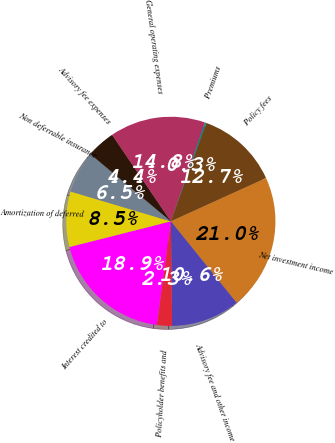<chart> <loc_0><loc_0><loc_500><loc_500><pie_chart><fcel>Premiums<fcel>Policy fees<fcel>Net investment income<fcel>Advisory fee and other income<fcel>Policyholder benefits and<fcel>Interest credited to<fcel>Amortization of deferred<fcel>Non deferrable insurance<fcel>Advisory fee expenses<fcel>General operating expenses<nl><fcel>0.26%<fcel>12.69%<fcel>20.98%<fcel>10.62%<fcel>2.34%<fcel>18.91%<fcel>8.55%<fcel>6.48%<fcel>4.41%<fcel>14.76%<nl></chart> 